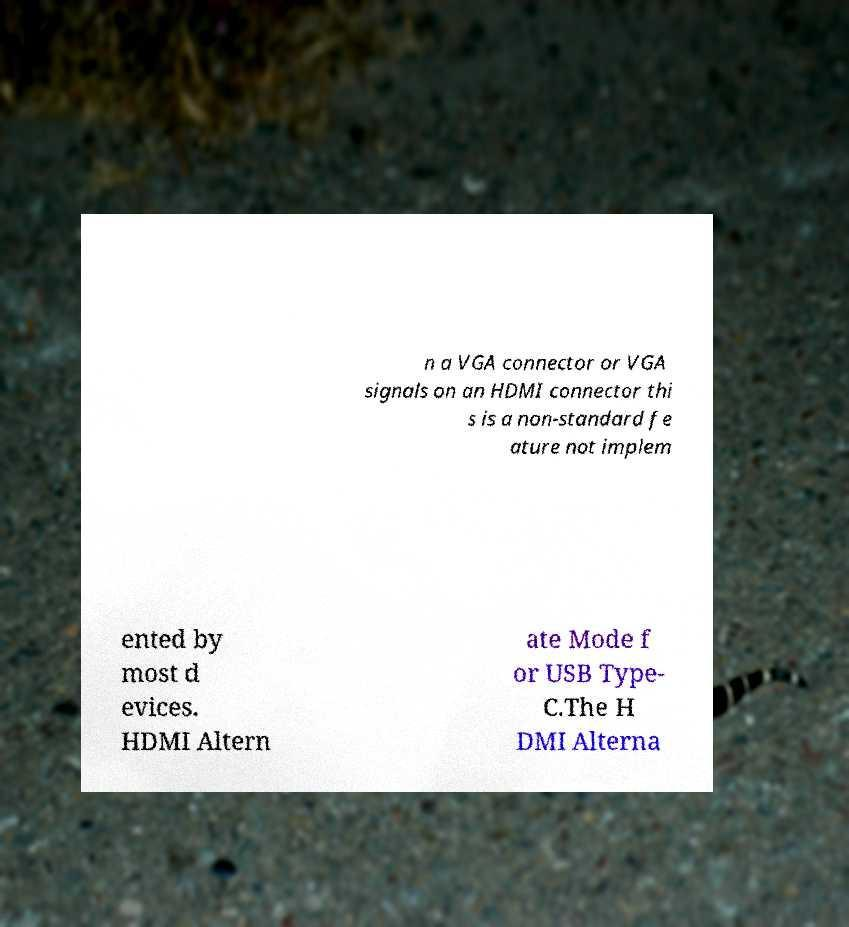I need the written content from this picture converted into text. Can you do that? n a VGA connector or VGA signals on an HDMI connector thi s is a non-standard fe ature not implem ented by most d evices. HDMI Altern ate Mode f or USB Type- C.The H DMI Alterna 